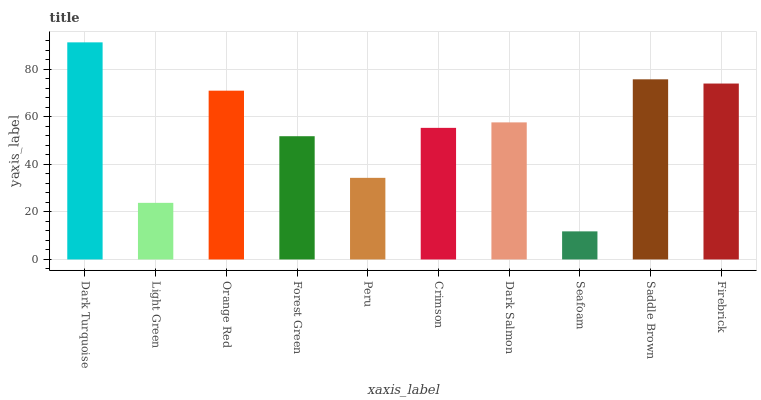Is Seafoam the minimum?
Answer yes or no. Yes. Is Dark Turquoise the maximum?
Answer yes or no. Yes. Is Light Green the minimum?
Answer yes or no. No. Is Light Green the maximum?
Answer yes or no. No. Is Dark Turquoise greater than Light Green?
Answer yes or no. Yes. Is Light Green less than Dark Turquoise?
Answer yes or no. Yes. Is Light Green greater than Dark Turquoise?
Answer yes or no. No. Is Dark Turquoise less than Light Green?
Answer yes or no. No. Is Dark Salmon the high median?
Answer yes or no. Yes. Is Crimson the low median?
Answer yes or no. Yes. Is Forest Green the high median?
Answer yes or no. No. Is Firebrick the low median?
Answer yes or no. No. 